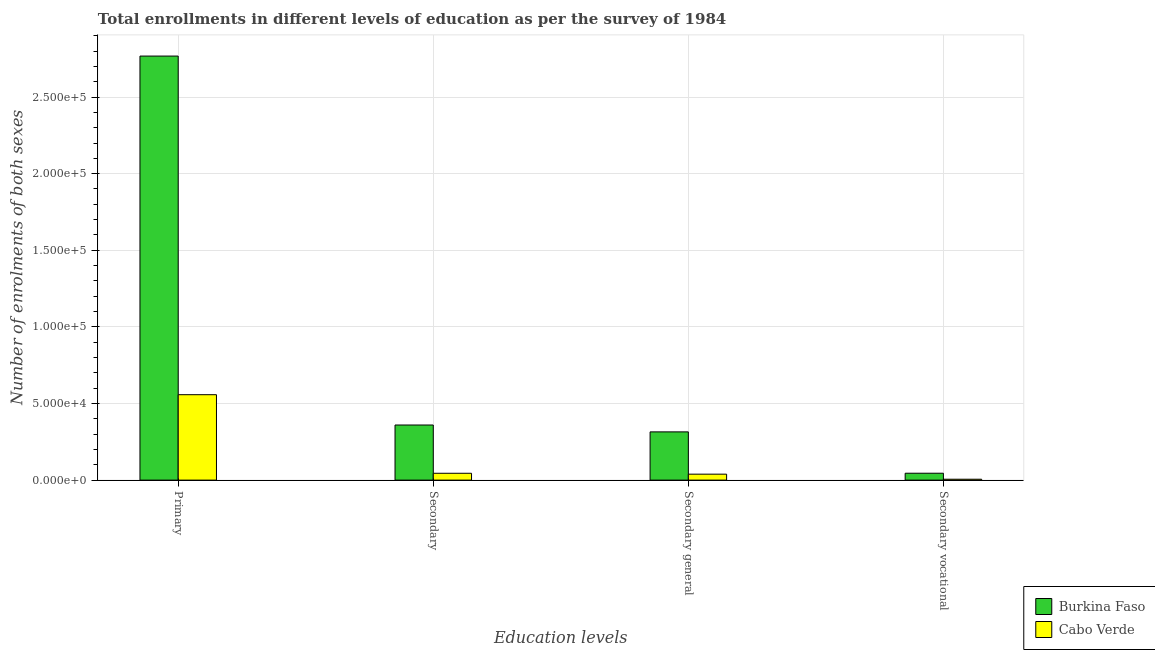How many bars are there on the 3rd tick from the right?
Your response must be concise. 2. What is the label of the 3rd group of bars from the left?
Provide a short and direct response. Secondary general. What is the number of enrolments in secondary general education in Burkina Faso?
Give a very brief answer. 3.15e+04. Across all countries, what is the maximum number of enrolments in secondary vocational education?
Your answer should be compact. 4492. Across all countries, what is the minimum number of enrolments in secondary vocational education?
Offer a terse response. 580. In which country was the number of enrolments in secondary education maximum?
Make the answer very short. Burkina Faso. In which country was the number of enrolments in primary education minimum?
Offer a terse response. Cabo Verde. What is the total number of enrolments in secondary vocational education in the graph?
Make the answer very short. 5072. What is the difference between the number of enrolments in secondary vocational education in Cabo Verde and that in Burkina Faso?
Your response must be concise. -3912. What is the difference between the number of enrolments in secondary vocational education in Burkina Faso and the number of enrolments in secondary general education in Cabo Verde?
Keep it short and to the point. 607. What is the average number of enrolments in secondary general education per country?
Ensure brevity in your answer.  1.77e+04. What is the difference between the number of enrolments in secondary general education and number of enrolments in primary education in Cabo Verde?
Offer a very short reply. -5.19e+04. What is the ratio of the number of enrolments in secondary education in Burkina Faso to that in Cabo Verde?
Provide a short and direct response. 8.06. What is the difference between the highest and the second highest number of enrolments in secondary vocational education?
Keep it short and to the point. 3912. What is the difference between the highest and the lowest number of enrolments in primary education?
Give a very brief answer. 2.21e+05. In how many countries, is the number of enrolments in primary education greater than the average number of enrolments in primary education taken over all countries?
Ensure brevity in your answer.  1. Is the sum of the number of enrolments in secondary vocational education in Burkina Faso and Cabo Verde greater than the maximum number of enrolments in secondary general education across all countries?
Give a very brief answer. No. What does the 2nd bar from the left in Secondary vocational represents?
Make the answer very short. Cabo Verde. What does the 1st bar from the right in Secondary represents?
Make the answer very short. Cabo Verde. Is it the case that in every country, the sum of the number of enrolments in primary education and number of enrolments in secondary education is greater than the number of enrolments in secondary general education?
Give a very brief answer. Yes. Are all the bars in the graph horizontal?
Your response must be concise. No. Does the graph contain any zero values?
Offer a terse response. No. Where does the legend appear in the graph?
Your answer should be very brief. Bottom right. How many legend labels are there?
Offer a very short reply. 2. How are the legend labels stacked?
Provide a succinct answer. Vertical. What is the title of the graph?
Give a very brief answer. Total enrollments in different levels of education as per the survey of 1984. Does "Maldives" appear as one of the legend labels in the graph?
Your response must be concise. No. What is the label or title of the X-axis?
Provide a short and direct response. Education levels. What is the label or title of the Y-axis?
Your response must be concise. Number of enrolments of both sexes. What is the Number of enrolments of both sexes of Burkina Faso in Primary?
Give a very brief answer. 2.77e+05. What is the Number of enrolments of both sexes in Cabo Verde in Primary?
Offer a very short reply. 5.58e+04. What is the Number of enrolments of both sexes in Burkina Faso in Secondary?
Your response must be concise. 3.60e+04. What is the Number of enrolments of both sexes of Cabo Verde in Secondary?
Keep it short and to the point. 4465. What is the Number of enrolments of both sexes of Burkina Faso in Secondary general?
Offer a very short reply. 3.15e+04. What is the Number of enrolments of both sexes of Cabo Verde in Secondary general?
Keep it short and to the point. 3885. What is the Number of enrolments of both sexes in Burkina Faso in Secondary vocational?
Your answer should be compact. 4492. What is the Number of enrolments of both sexes of Cabo Verde in Secondary vocational?
Your response must be concise. 580. Across all Education levels, what is the maximum Number of enrolments of both sexes in Burkina Faso?
Keep it short and to the point. 2.77e+05. Across all Education levels, what is the maximum Number of enrolments of both sexes in Cabo Verde?
Ensure brevity in your answer.  5.58e+04. Across all Education levels, what is the minimum Number of enrolments of both sexes of Burkina Faso?
Offer a terse response. 4492. Across all Education levels, what is the minimum Number of enrolments of both sexes in Cabo Verde?
Provide a short and direct response. 580. What is the total Number of enrolments of both sexes of Burkina Faso in the graph?
Your answer should be very brief. 3.49e+05. What is the total Number of enrolments of both sexes of Cabo Verde in the graph?
Keep it short and to the point. 6.47e+04. What is the difference between the Number of enrolments of both sexes in Burkina Faso in Primary and that in Secondary?
Offer a terse response. 2.41e+05. What is the difference between the Number of enrolments of both sexes in Cabo Verde in Primary and that in Secondary?
Give a very brief answer. 5.13e+04. What is the difference between the Number of enrolments of both sexes of Burkina Faso in Primary and that in Secondary general?
Keep it short and to the point. 2.45e+05. What is the difference between the Number of enrolments of both sexes of Cabo Verde in Primary and that in Secondary general?
Keep it short and to the point. 5.19e+04. What is the difference between the Number of enrolments of both sexes in Burkina Faso in Primary and that in Secondary vocational?
Your response must be concise. 2.72e+05. What is the difference between the Number of enrolments of both sexes of Cabo Verde in Primary and that in Secondary vocational?
Your answer should be very brief. 5.52e+04. What is the difference between the Number of enrolments of both sexes of Burkina Faso in Secondary and that in Secondary general?
Provide a succinct answer. 4492. What is the difference between the Number of enrolments of both sexes of Cabo Verde in Secondary and that in Secondary general?
Your answer should be compact. 580. What is the difference between the Number of enrolments of both sexes of Burkina Faso in Secondary and that in Secondary vocational?
Ensure brevity in your answer.  3.15e+04. What is the difference between the Number of enrolments of both sexes of Cabo Verde in Secondary and that in Secondary vocational?
Provide a short and direct response. 3885. What is the difference between the Number of enrolments of both sexes in Burkina Faso in Secondary general and that in Secondary vocational?
Provide a short and direct response. 2.70e+04. What is the difference between the Number of enrolments of both sexes in Cabo Verde in Secondary general and that in Secondary vocational?
Offer a very short reply. 3305. What is the difference between the Number of enrolments of both sexes of Burkina Faso in Primary and the Number of enrolments of both sexes of Cabo Verde in Secondary?
Your answer should be compact. 2.72e+05. What is the difference between the Number of enrolments of both sexes in Burkina Faso in Primary and the Number of enrolments of both sexes in Cabo Verde in Secondary general?
Provide a short and direct response. 2.73e+05. What is the difference between the Number of enrolments of both sexes of Burkina Faso in Primary and the Number of enrolments of both sexes of Cabo Verde in Secondary vocational?
Your answer should be very brief. 2.76e+05. What is the difference between the Number of enrolments of both sexes in Burkina Faso in Secondary and the Number of enrolments of both sexes in Cabo Verde in Secondary general?
Give a very brief answer. 3.21e+04. What is the difference between the Number of enrolments of both sexes in Burkina Faso in Secondary and the Number of enrolments of both sexes in Cabo Verde in Secondary vocational?
Ensure brevity in your answer.  3.54e+04. What is the difference between the Number of enrolments of both sexes in Burkina Faso in Secondary general and the Number of enrolments of both sexes in Cabo Verde in Secondary vocational?
Your answer should be very brief. 3.09e+04. What is the average Number of enrolments of both sexes in Burkina Faso per Education levels?
Offer a very short reply. 8.72e+04. What is the average Number of enrolments of both sexes of Cabo Verde per Education levels?
Give a very brief answer. 1.62e+04. What is the difference between the Number of enrolments of both sexes in Burkina Faso and Number of enrolments of both sexes in Cabo Verde in Primary?
Give a very brief answer. 2.21e+05. What is the difference between the Number of enrolments of both sexes in Burkina Faso and Number of enrolments of both sexes in Cabo Verde in Secondary?
Provide a succinct answer. 3.15e+04. What is the difference between the Number of enrolments of both sexes of Burkina Faso and Number of enrolments of both sexes of Cabo Verde in Secondary general?
Keep it short and to the point. 2.76e+04. What is the difference between the Number of enrolments of both sexes in Burkina Faso and Number of enrolments of both sexes in Cabo Verde in Secondary vocational?
Give a very brief answer. 3912. What is the ratio of the Number of enrolments of both sexes in Burkina Faso in Primary to that in Secondary?
Your answer should be compact. 7.69. What is the ratio of the Number of enrolments of both sexes in Cabo Verde in Primary to that in Secondary?
Your response must be concise. 12.49. What is the ratio of the Number of enrolments of both sexes in Burkina Faso in Primary to that in Secondary general?
Offer a very short reply. 8.79. What is the ratio of the Number of enrolments of both sexes of Cabo Verde in Primary to that in Secondary general?
Provide a short and direct response. 14.35. What is the ratio of the Number of enrolments of both sexes in Burkina Faso in Primary to that in Secondary vocational?
Your answer should be very brief. 61.61. What is the ratio of the Number of enrolments of both sexes of Cabo Verde in Primary to that in Secondary vocational?
Offer a terse response. 96.12. What is the ratio of the Number of enrolments of both sexes in Burkina Faso in Secondary to that in Secondary general?
Provide a succinct answer. 1.14. What is the ratio of the Number of enrolments of both sexes in Cabo Verde in Secondary to that in Secondary general?
Make the answer very short. 1.15. What is the ratio of the Number of enrolments of both sexes of Burkina Faso in Secondary to that in Secondary vocational?
Your answer should be compact. 8.01. What is the ratio of the Number of enrolments of both sexes of Cabo Verde in Secondary to that in Secondary vocational?
Your answer should be very brief. 7.7. What is the ratio of the Number of enrolments of both sexes in Burkina Faso in Secondary general to that in Secondary vocational?
Ensure brevity in your answer.  7.01. What is the ratio of the Number of enrolments of both sexes in Cabo Verde in Secondary general to that in Secondary vocational?
Ensure brevity in your answer.  6.7. What is the difference between the highest and the second highest Number of enrolments of both sexes of Burkina Faso?
Offer a very short reply. 2.41e+05. What is the difference between the highest and the second highest Number of enrolments of both sexes of Cabo Verde?
Provide a short and direct response. 5.13e+04. What is the difference between the highest and the lowest Number of enrolments of both sexes of Burkina Faso?
Provide a short and direct response. 2.72e+05. What is the difference between the highest and the lowest Number of enrolments of both sexes in Cabo Verde?
Provide a succinct answer. 5.52e+04. 